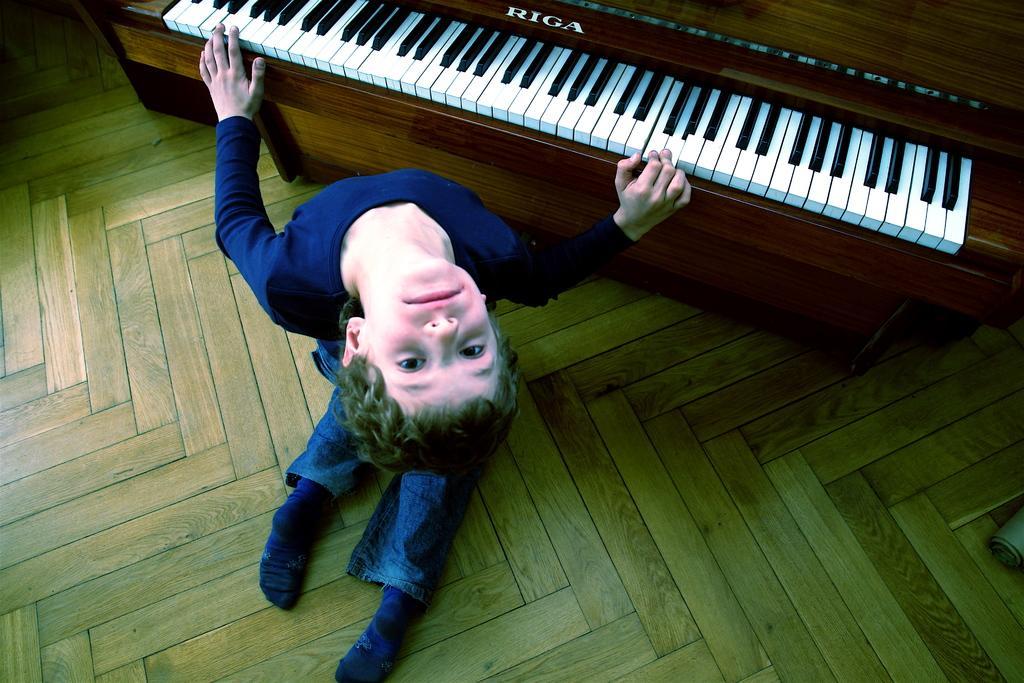Describe this image in one or two sentences. In this picture there is a boy kneeling down on the floor and playing piano. On the piano there are keys and text "Riga" on it. There is a wooden floor in the image. 